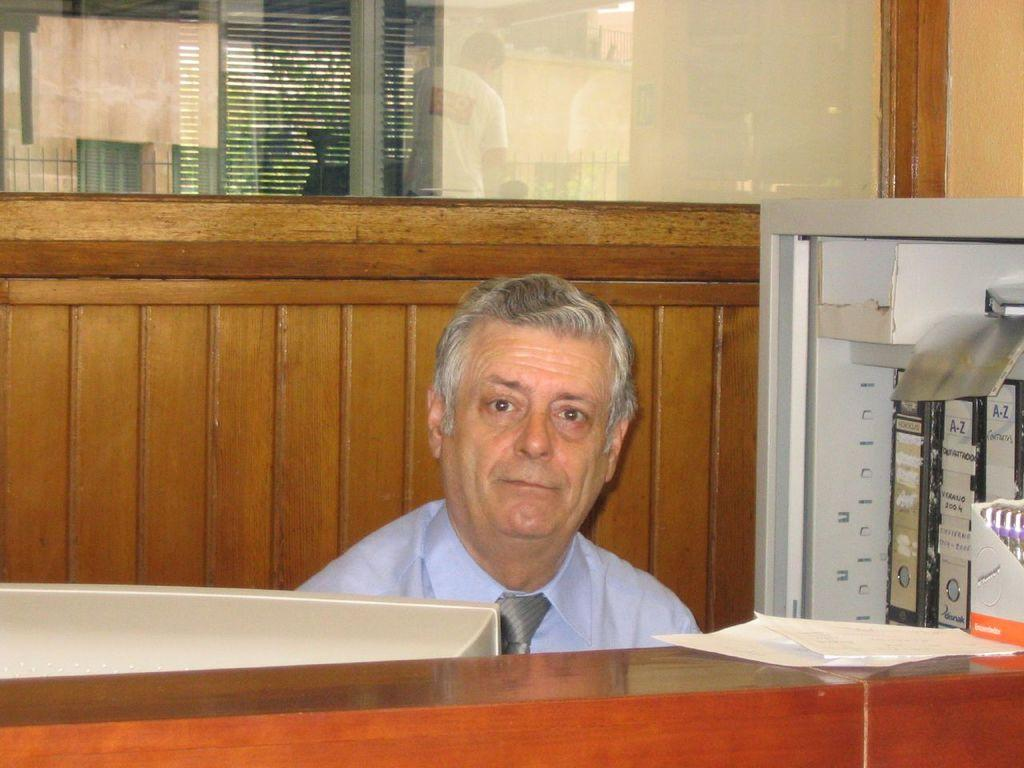Who or what is in the image? There is a person in the image. What is the person interacting with in the image? There is a computer monitor in front of the person. What items can be seen on the table in the image? There are files and papers on the table. What type of wall is behind the person in the image? There is a wooden wall behind the person. Is there any natural light visible in the image? Yes, there is a glass window in the wooden wall, which allows natural light to enter the room. What type of group experience can be observed in the image? There is no group experience present in the image; it features a person interacting with a computer monitor and items on a table. 